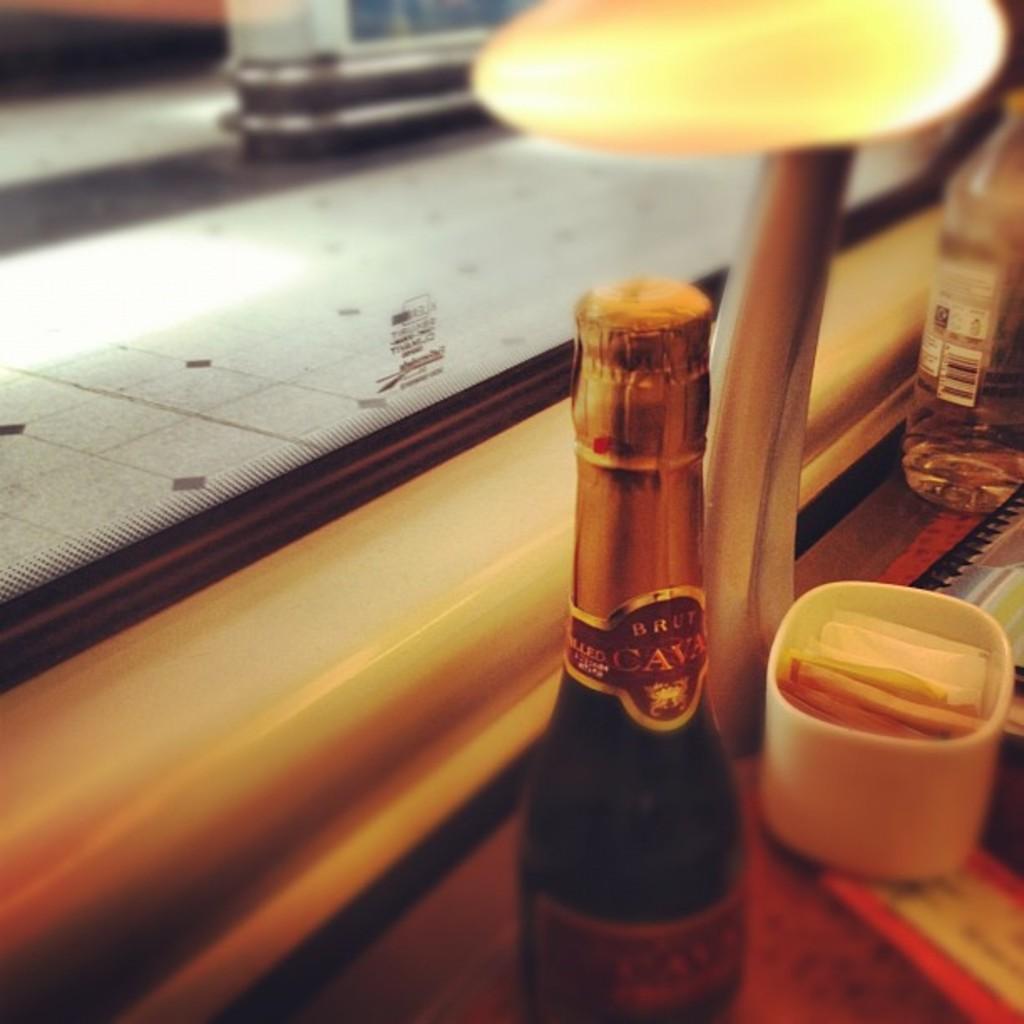What kind of wine is this?
Keep it short and to the point. Brut cava. How many letters in the first word in the name?
Provide a succinct answer. 4. 